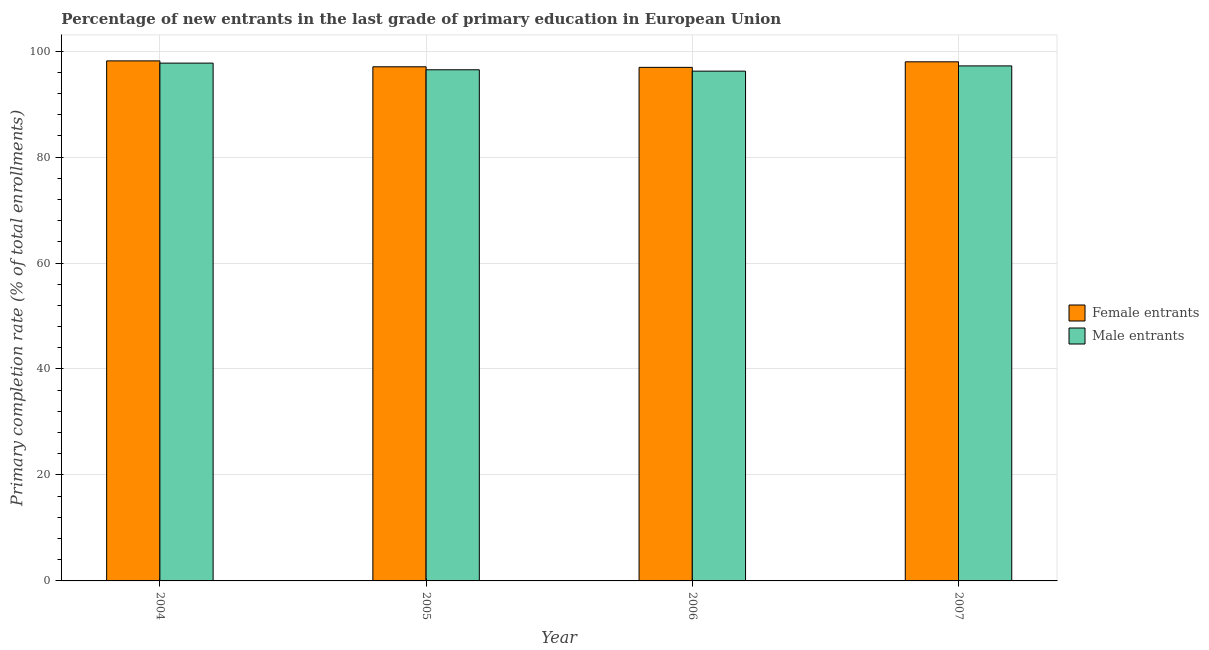How many groups of bars are there?
Your answer should be compact. 4. Are the number of bars on each tick of the X-axis equal?
Your answer should be compact. Yes. How many bars are there on the 4th tick from the left?
Your answer should be very brief. 2. What is the label of the 1st group of bars from the left?
Make the answer very short. 2004. In how many cases, is the number of bars for a given year not equal to the number of legend labels?
Offer a terse response. 0. What is the primary completion rate of male entrants in 2006?
Keep it short and to the point. 96.21. Across all years, what is the maximum primary completion rate of female entrants?
Give a very brief answer. 98.15. Across all years, what is the minimum primary completion rate of female entrants?
Give a very brief answer. 96.92. In which year was the primary completion rate of male entrants maximum?
Make the answer very short. 2004. What is the total primary completion rate of male entrants in the graph?
Ensure brevity in your answer.  387.61. What is the difference between the primary completion rate of male entrants in 2004 and that in 2006?
Keep it short and to the point. 1.52. What is the difference between the primary completion rate of male entrants in 2007 and the primary completion rate of female entrants in 2004?
Make the answer very short. -0.52. What is the average primary completion rate of female entrants per year?
Offer a very short reply. 97.52. In the year 2005, what is the difference between the primary completion rate of male entrants and primary completion rate of female entrants?
Offer a terse response. 0. In how many years, is the primary completion rate of male entrants greater than 4 %?
Offer a very short reply. 4. What is the ratio of the primary completion rate of male entrants in 2004 to that in 2006?
Your response must be concise. 1.02. Is the difference between the primary completion rate of male entrants in 2004 and 2006 greater than the difference between the primary completion rate of female entrants in 2004 and 2006?
Your answer should be compact. No. What is the difference between the highest and the second highest primary completion rate of male entrants?
Your answer should be very brief. 0.52. What is the difference between the highest and the lowest primary completion rate of male entrants?
Ensure brevity in your answer.  1.52. In how many years, is the primary completion rate of male entrants greater than the average primary completion rate of male entrants taken over all years?
Your answer should be very brief. 2. What does the 2nd bar from the left in 2005 represents?
Your response must be concise. Male entrants. What does the 2nd bar from the right in 2004 represents?
Your answer should be compact. Female entrants. Are all the bars in the graph horizontal?
Provide a succinct answer. No. What is the difference between two consecutive major ticks on the Y-axis?
Ensure brevity in your answer.  20. Where does the legend appear in the graph?
Keep it short and to the point. Center right. How many legend labels are there?
Your answer should be very brief. 2. What is the title of the graph?
Ensure brevity in your answer.  Percentage of new entrants in the last grade of primary education in European Union. What is the label or title of the Y-axis?
Keep it short and to the point. Primary completion rate (% of total enrollments). What is the Primary completion rate (% of total enrollments) of Female entrants in 2004?
Your response must be concise. 98.15. What is the Primary completion rate (% of total enrollments) in Male entrants in 2004?
Your response must be concise. 97.73. What is the Primary completion rate (% of total enrollments) of Female entrants in 2005?
Make the answer very short. 97.03. What is the Primary completion rate (% of total enrollments) of Male entrants in 2005?
Provide a short and direct response. 96.47. What is the Primary completion rate (% of total enrollments) of Female entrants in 2006?
Provide a short and direct response. 96.92. What is the Primary completion rate (% of total enrollments) of Male entrants in 2006?
Your answer should be compact. 96.21. What is the Primary completion rate (% of total enrollments) of Female entrants in 2007?
Offer a very short reply. 97.97. What is the Primary completion rate (% of total enrollments) in Male entrants in 2007?
Keep it short and to the point. 97.2. Across all years, what is the maximum Primary completion rate (% of total enrollments) in Female entrants?
Keep it short and to the point. 98.15. Across all years, what is the maximum Primary completion rate (% of total enrollments) in Male entrants?
Keep it short and to the point. 97.73. Across all years, what is the minimum Primary completion rate (% of total enrollments) of Female entrants?
Give a very brief answer. 96.92. Across all years, what is the minimum Primary completion rate (% of total enrollments) of Male entrants?
Offer a terse response. 96.21. What is the total Primary completion rate (% of total enrollments) in Female entrants in the graph?
Ensure brevity in your answer.  390.08. What is the total Primary completion rate (% of total enrollments) in Male entrants in the graph?
Provide a short and direct response. 387.61. What is the difference between the Primary completion rate (% of total enrollments) in Female entrants in 2004 and that in 2005?
Make the answer very short. 1.11. What is the difference between the Primary completion rate (% of total enrollments) of Male entrants in 2004 and that in 2005?
Keep it short and to the point. 1.26. What is the difference between the Primary completion rate (% of total enrollments) in Female entrants in 2004 and that in 2006?
Keep it short and to the point. 1.22. What is the difference between the Primary completion rate (% of total enrollments) of Male entrants in 2004 and that in 2006?
Give a very brief answer. 1.52. What is the difference between the Primary completion rate (% of total enrollments) of Female entrants in 2004 and that in 2007?
Provide a short and direct response. 0.18. What is the difference between the Primary completion rate (% of total enrollments) in Male entrants in 2004 and that in 2007?
Keep it short and to the point. 0.52. What is the difference between the Primary completion rate (% of total enrollments) of Female entrants in 2005 and that in 2006?
Ensure brevity in your answer.  0.11. What is the difference between the Primary completion rate (% of total enrollments) of Male entrants in 2005 and that in 2006?
Give a very brief answer. 0.26. What is the difference between the Primary completion rate (% of total enrollments) in Female entrants in 2005 and that in 2007?
Your response must be concise. -0.94. What is the difference between the Primary completion rate (% of total enrollments) of Male entrants in 2005 and that in 2007?
Give a very brief answer. -0.73. What is the difference between the Primary completion rate (% of total enrollments) of Female entrants in 2006 and that in 2007?
Give a very brief answer. -1.05. What is the difference between the Primary completion rate (% of total enrollments) in Male entrants in 2006 and that in 2007?
Offer a terse response. -0.99. What is the difference between the Primary completion rate (% of total enrollments) in Female entrants in 2004 and the Primary completion rate (% of total enrollments) in Male entrants in 2005?
Your response must be concise. 1.68. What is the difference between the Primary completion rate (% of total enrollments) of Female entrants in 2004 and the Primary completion rate (% of total enrollments) of Male entrants in 2006?
Ensure brevity in your answer.  1.94. What is the difference between the Primary completion rate (% of total enrollments) in Female entrants in 2004 and the Primary completion rate (% of total enrollments) in Male entrants in 2007?
Give a very brief answer. 0.95. What is the difference between the Primary completion rate (% of total enrollments) of Female entrants in 2005 and the Primary completion rate (% of total enrollments) of Male entrants in 2006?
Provide a succinct answer. 0.82. What is the difference between the Primary completion rate (% of total enrollments) of Female entrants in 2005 and the Primary completion rate (% of total enrollments) of Male entrants in 2007?
Your answer should be very brief. -0.17. What is the difference between the Primary completion rate (% of total enrollments) in Female entrants in 2006 and the Primary completion rate (% of total enrollments) in Male entrants in 2007?
Offer a very short reply. -0.28. What is the average Primary completion rate (% of total enrollments) of Female entrants per year?
Give a very brief answer. 97.52. What is the average Primary completion rate (% of total enrollments) of Male entrants per year?
Your answer should be compact. 96.9. In the year 2004, what is the difference between the Primary completion rate (% of total enrollments) in Female entrants and Primary completion rate (% of total enrollments) in Male entrants?
Offer a terse response. 0.42. In the year 2005, what is the difference between the Primary completion rate (% of total enrollments) of Female entrants and Primary completion rate (% of total enrollments) of Male entrants?
Offer a very short reply. 0.57. In the year 2006, what is the difference between the Primary completion rate (% of total enrollments) of Female entrants and Primary completion rate (% of total enrollments) of Male entrants?
Your response must be concise. 0.71. In the year 2007, what is the difference between the Primary completion rate (% of total enrollments) in Female entrants and Primary completion rate (% of total enrollments) in Male entrants?
Your answer should be very brief. 0.77. What is the ratio of the Primary completion rate (% of total enrollments) in Female entrants in 2004 to that in 2005?
Provide a succinct answer. 1.01. What is the ratio of the Primary completion rate (% of total enrollments) of Male entrants in 2004 to that in 2005?
Provide a short and direct response. 1.01. What is the ratio of the Primary completion rate (% of total enrollments) in Female entrants in 2004 to that in 2006?
Make the answer very short. 1.01. What is the ratio of the Primary completion rate (% of total enrollments) of Male entrants in 2004 to that in 2006?
Your answer should be very brief. 1.02. What is the ratio of the Primary completion rate (% of total enrollments) in Male entrants in 2004 to that in 2007?
Your response must be concise. 1.01. What is the ratio of the Primary completion rate (% of total enrollments) of Female entrants in 2005 to that in 2006?
Offer a very short reply. 1. What is the ratio of the Primary completion rate (% of total enrollments) of Female entrants in 2005 to that in 2007?
Your answer should be very brief. 0.99. What is the ratio of the Primary completion rate (% of total enrollments) in Female entrants in 2006 to that in 2007?
Give a very brief answer. 0.99. What is the difference between the highest and the second highest Primary completion rate (% of total enrollments) of Female entrants?
Offer a very short reply. 0.18. What is the difference between the highest and the second highest Primary completion rate (% of total enrollments) of Male entrants?
Provide a succinct answer. 0.52. What is the difference between the highest and the lowest Primary completion rate (% of total enrollments) of Female entrants?
Your answer should be compact. 1.22. What is the difference between the highest and the lowest Primary completion rate (% of total enrollments) of Male entrants?
Provide a succinct answer. 1.52. 